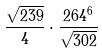<formula> <loc_0><loc_0><loc_500><loc_500>\frac { \sqrt { 2 3 9 } } { 4 } \cdot \frac { 2 6 4 ^ { 6 } } { \sqrt { 3 0 2 } }</formula> 